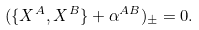Convert formula to latex. <formula><loc_0><loc_0><loc_500><loc_500>( \{ X ^ { A } , X ^ { B } \} + \alpha ^ { A B } ) _ { \pm } = 0 .</formula> 